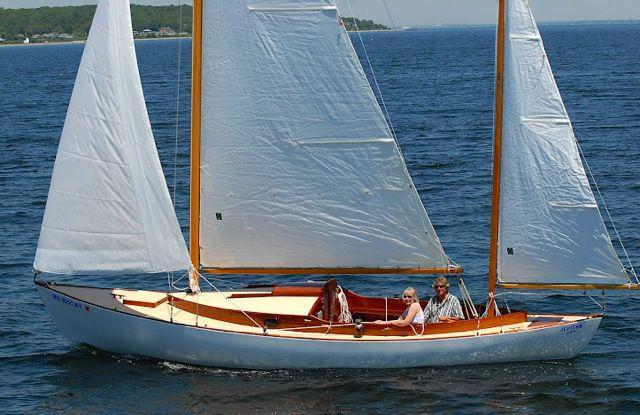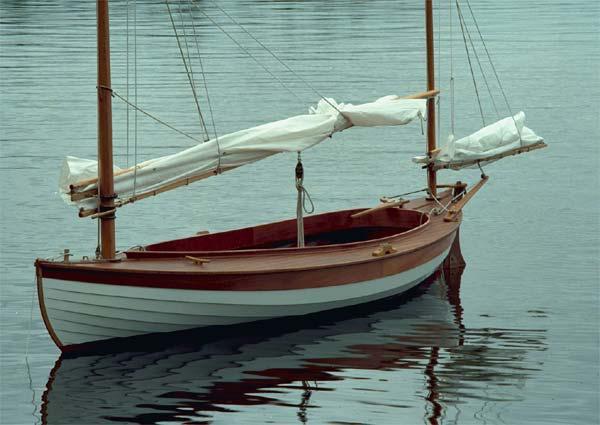The first image is the image on the left, the second image is the image on the right. Assess this claim about the two images: "There are 5 raised sails in the image pair". Correct or not? Answer yes or no. No. 